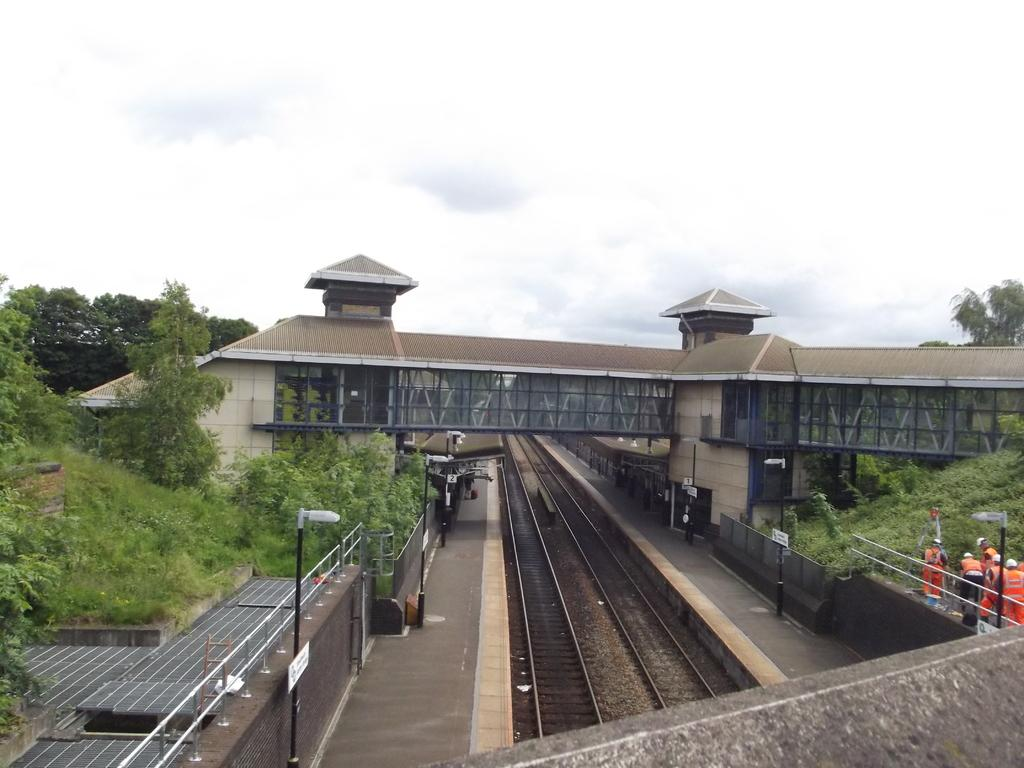What type of transportation infrastructure is depicted in the image? There are railway tracks and platforms in the image. What structures are present to provide illumination in the image? Light poles are visible in the image. What type of barrier is present in the image? Fences are present in the image. Are there any people in the image? Yes, there are people in the image. What type of structure is present for crossing the railway tracks in the image? There is a bridge in the image. What type of natural element is visible in the image? Trees are visible in the image. What type of objects can be seen in the image? There are objects in the image, but their specific nature is not mentioned in the facts. What can be seen in the background of the image? The sky is visible in the background of the image. What type of activity are the people engaged in on the view in the image? The provided facts do not mention any specific activity that the people are engaged in, nor do they mention a "view" in the image. 